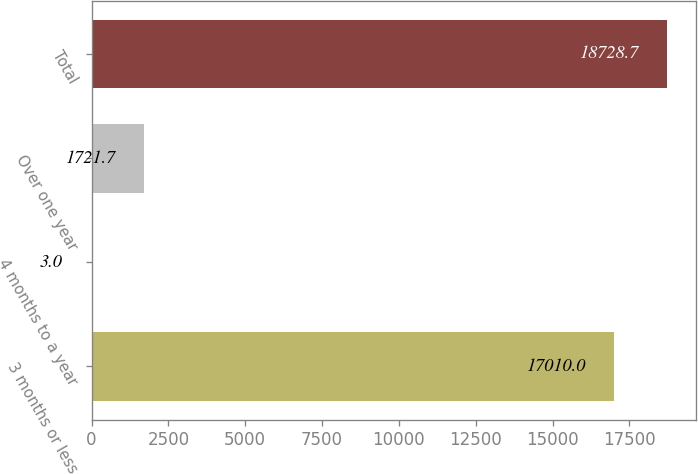<chart> <loc_0><loc_0><loc_500><loc_500><bar_chart><fcel>3 months or less<fcel>4 months to a year<fcel>Over one year<fcel>Total<nl><fcel>17010<fcel>3<fcel>1721.7<fcel>18728.7<nl></chart> 